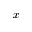<formula> <loc_0><loc_0><loc_500><loc_500>x</formula> 